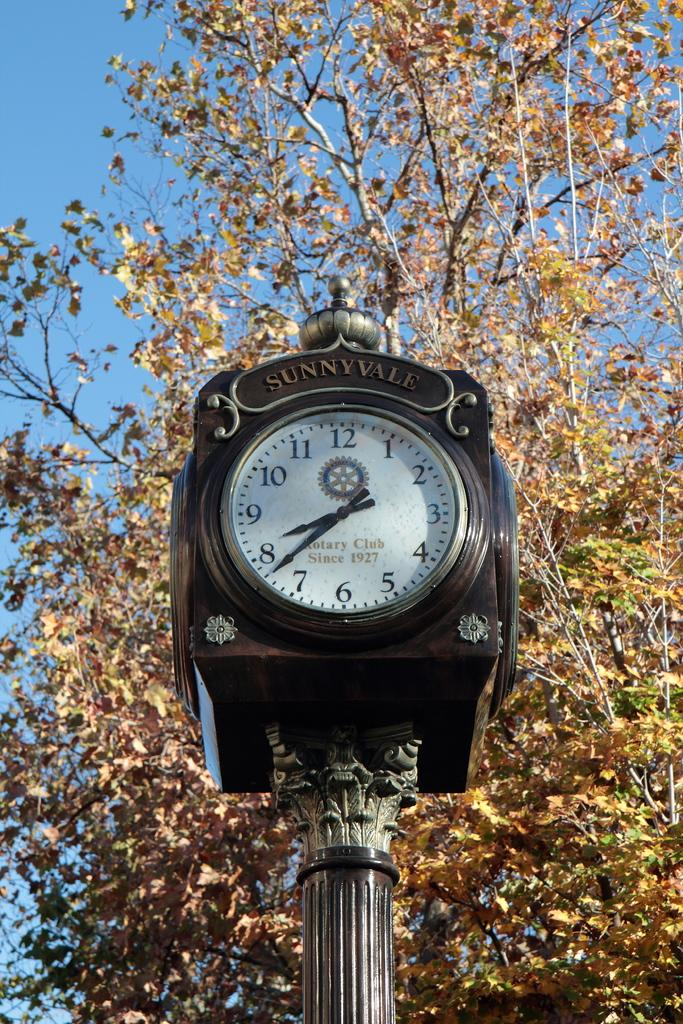Provide a one-sentence caption for the provided image. A black clock labelled Sunnyville on a pole. 